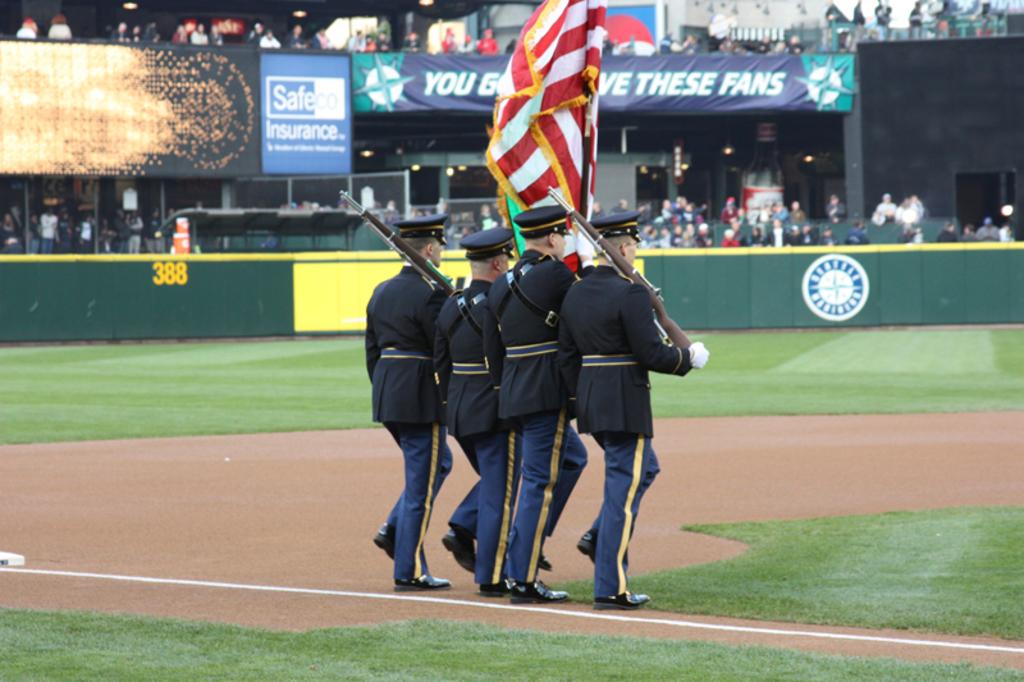How many feet is it from home plate to the outfield wall beneath the safe insurance ad?
Offer a terse response. 388. What company is advertised on the square blue and white sign?
Your answer should be very brief. Safeco insurance. 